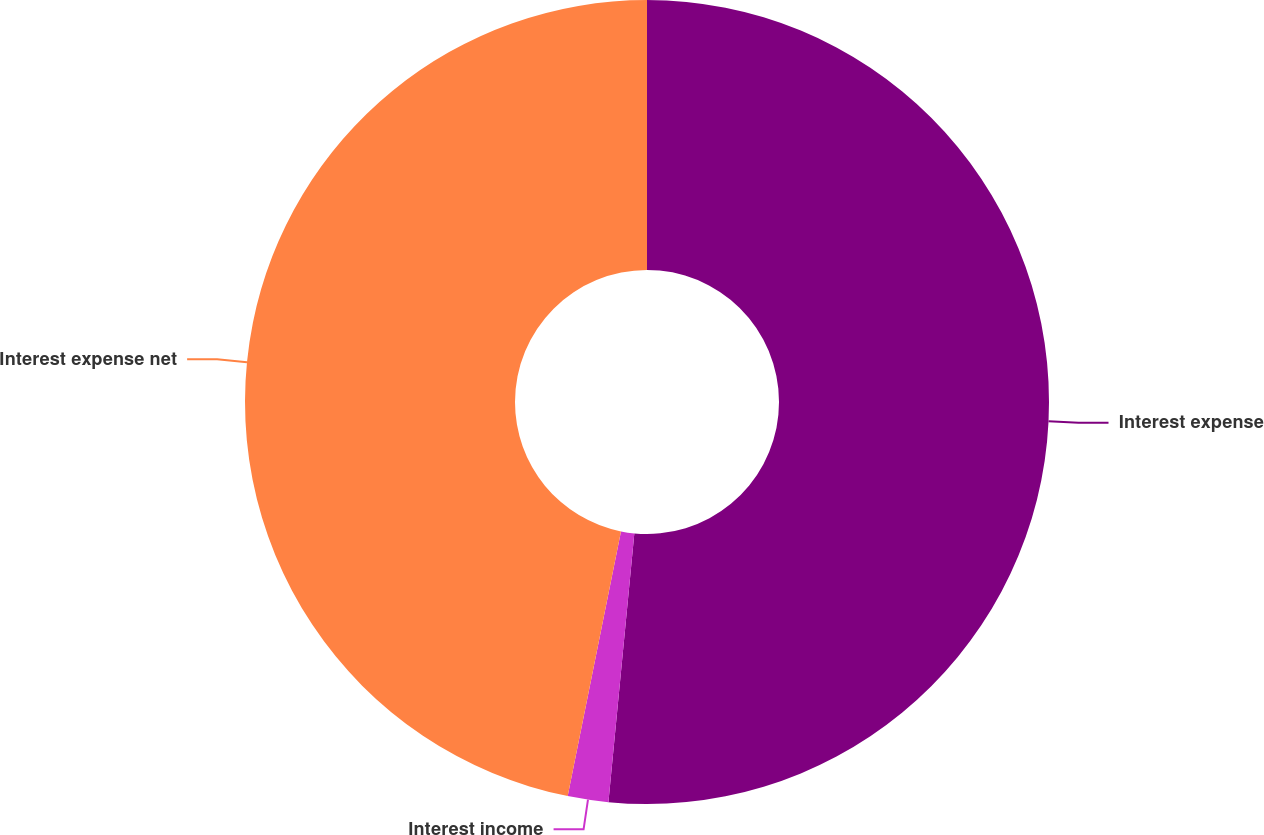Convert chart to OTSL. <chart><loc_0><loc_0><loc_500><loc_500><pie_chart><fcel>Interest expense<fcel>Interest income<fcel>Interest expense net<nl><fcel>51.53%<fcel>1.63%<fcel>46.84%<nl></chart> 